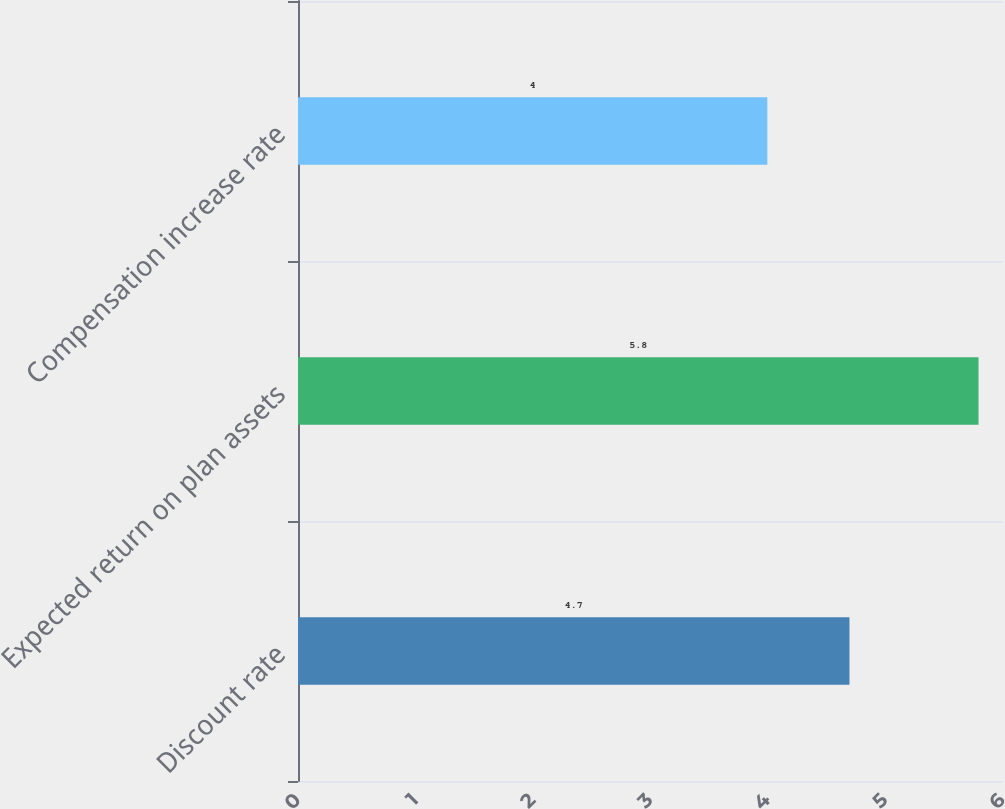Convert chart to OTSL. <chart><loc_0><loc_0><loc_500><loc_500><bar_chart><fcel>Discount rate<fcel>Expected return on plan assets<fcel>Compensation increase rate<nl><fcel>4.7<fcel>5.8<fcel>4<nl></chart> 